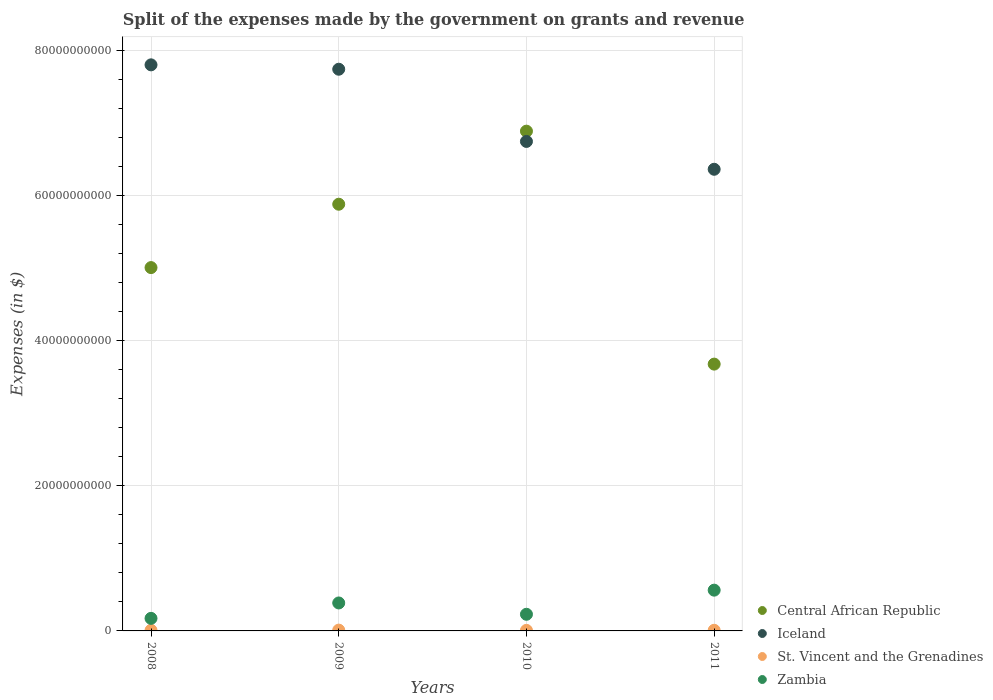How many different coloured dotlines are there?
Make the answer very short. 4. What is the expenses made by the government on grants and revenue in St. Vincent and the Grenadines in 2010?
Offer a terse response. 7.65e+07. Across all years, what is the maximum expenses made by the government on grants and revenue in Iceland?
Make the answer very short. 7.80e+1. Across all years, what is the minimum expenses made by the government on grants and revenue in Iceland?
Your answer should be compact. 6.36e+1. In which year was the expenses made by the government on grants and revenue in St. Vincent and the Grenadines maximum?
Your answer should be compact. 2009. In which year was the expenses made by the government on grants and revenue in Iceland minimum?
Your answer should be very brief. 2011. What is the total expenses made by the government on grants and revenue in Iceland in the graph?
Provide a short and direct response. 2.87e+11. What is the difference between the expenses made by the government on grants and revenue in Central African Republic in 2011 and the expenses made by the government on grants and revenue in Zambia in 2008?
Keep it short and to the point. 3.51e+1. What is the average expenses made by the government on grants and revenue in St. Vincent and the Grenadines per year?
Your answer should be compact. 9.02e+07. In the year 2008, what is the difference between the expenses made by the government on grants and revenue in St. Vincent and the Grenadines and expenses made by the government on grants and revenue in Central African Republic?
Provide a succinct answer. -5.00e+1. In how many years, is the expenses made by the government on grants and revenue in Central African Republic greater than 8000000000 $?
Make the answer very short. 4. What is the ratio of the expenses made by the government on grants and revenue in Iceland in 2008 to that in 2009?
Ensure brevity in your answer.  1.01. Is the expenses made by the government on grants and revenue in Central African Republic in 2008 less than that in 2010?
Offer a terse response. Yes. What is the difference between the highest and the second highest expenses made by the government on grants and revenue in Iceland?
Your response must be concise. 6.04e+08. What is the difference between the highest and the lowest expenses made by the government on grants and revenue in Zambia?
Ensure brevity in your answer.  3.89e+09. In how many years, is the expenses made by the government on grants and revenue in St. Vincent and the Grenadines greater than the average expenses made by the government on grants and revenue in St. Vincent and the Grenadines taken over all years?
Provide a short and direct response. 1. Is the sum of the expenses made by the government on grants and revenue in St. Vincent and the Grenadines in 2008 and 2010 greater than the maximum expenses made by the government on grants and revenue in Zambia across all years?
Your response must be concise. No. Is it the case that in every year, the sum of the expenses made by the government on grants and revenue in Central African Republic and expenses made by the government on grants and revenue in St. Vincent and the Grenadines  is greater than the sum of expenses made by the government on grants and revenue in Zambia and expenses made by the government on grants and revenue in Iceland?
Your answer should be compact. No. Is it the case that in every year, the sum of the expenses made by the government on grants and revenue in Iceland and expenses made by the government on grants and revenue in St. Vincent and the Grenadines  is greater than the expenses made by the government on grants and revenue in Zambia?
Provide a short and direct response. Yes. Does the expenses made by the government on grants and revenue in Zambia monotonically increase over the years?
Make the answer very short. No. Is the expenses made by the government on grants and revenue in Iceland strictly greater than the expenses made by the government on grants and revenue in St. Vincent and the Grenadines over the years?
Offer a very short reply. Yes. Is the expenses made by the government on grants and revenue in St. Vincent and the Grenadines strictly less than the expenses made by the government on grants and revenue in Zambia over the years?
Provide a short and direct response. Yes. How many years are there in the graph?
Your answer should be very brief. 4. What is the difference between two consecutive major ticks on the Y-axis?
Your answer should be compact. 2.00e+1. Are the values on the major ticks of Y-axis written in scientific E-notation?
Offer a very short reply. No. Does the graph contain grids?
Your response must be concise. Yes. Where does the legend appear in the graph?
Ensure brevity in your answer.  Bottom right. How many legend labels are there?
Provide a succinct answer. 4. How are the legend labels stacked?
Offer a terse response. Vertical. What is the title of the graph?
Offer a very short reply. Split of the expenses made by the government on grants and revenue. Does "South Asia" appear as one of the legend labels in the graph?
Keep it short and to the point. No. What is the label or title of the X-axis?
Provide a short and direct response. Years. What is the label or title of the Y-axis?
Your answer should be very brief. Expenses (in $). What is the Expenses (in $) in Central African Republic in 2008?
Offer a terse response. 5.01e+1. What is the Expenses (in $) in Iceland in 2008?
Offer a terse response. 7.80e+1. What is the Expenses (in $) of St. Vincent and the Grenadines in 2008?
Ensure brevity in your answer.  8.68e+07. What is the Expenses (in $) of Zambia in 2008?
Offer a terse response. 1.73e+09. What is the Expenses (in $) of Central African Republic in 2009?
Make the answer very short. 5.88e+1. What is the Expenses (in $) of Iceland in 2009?
Ensure brevity in your answer.  7.74e+1. What is the Expenses (in $) of St. Vincent and the Grenadines in 2009?
Provide a succinct answer. 1.11e+08. What is the Expenses (in $) of Zambia in 2009?
Your answer should be very brief. 3.86e+09. What is the Expenses (in $) of Central African Republic in 2010?
Provide a succinct answer. 6.89e+1. What is the Expenses (in $) of Iceland in 2010?
Your response must be concise. 6.75e+1. What is the Expenses (in $) of St. Vincent and the Grenadines in 2010?
Make the answer very short. 7.65e+07. What is the Expenses (in $) in Zambia in 2010?
Offer a very short reply. 2.29e+09. What is the Expenses (in $) in Central African Republic in 2011?
Your response must be concise. 3.68e+1. What is the Expenses (in $) in Iceland in 2011?
Offer a terse response. 6.36e+1. What is the Expenses (in $) of St. Vincent and the Grenadines in 2011?
Your response must be concise. 8.65e+07. What is the Expenses (in $) of Zambia in 2011?
Provide a short and direct response. 5.62e+09. Across all years, what is the maximum Expenses (in $) of Central African Republic?
Your response must be concise. 6.89e+1. Across all years, what is the maximum Expenses (in $) in Iceland?
Your answer should be very brief. 7.80e+1. Across all years, what is the maximum Expenses (in $) in St. Vincent and the Grenadines?
Provide a succinct answer. 1.11e+08. Across all years, what is the maximum Expenses (in $) in Zambia?
Your answer should be compact. 5.62e+09. Across all years, what is the minimum Expenses (in $) in Central African Republic?
Provide a short and direct response. 3.68e+1. Across all years, what is the minimum Expenses (in $) of Iceland?
Your answer should be compact. 6.36e+1. Across all years, what is the minimum Expenses (in $) of St. Vincent and the Grenadines?
Your response must be concise. 7.65e+07. Across all years, what is the minimum Expenses (in $) of Zambia?
Provide a short and direct response. 1.73e+09. What is the total Expenses (in $) of Central African Republic in the graph?
Your response must be concise. 2.15e+11. What is the total Expenses (in $) in Iceland in the graph?
Offer a terse response. 2.87e+11. What is the total Expenses (in $) in St. Vincent and the Grenadines in the graph?
Provide a short and direct response. 3.61e+08. What is the total Expenses (in $) in Zambia in the graph?
Ensure brevity in your answer.  1.35e+1. What is the difference between the Expenses (in $) in Central African Republic in 2008 and that in 2009?
Keep it short and to the point. -8.74e+09. What is the difference between the Expenses (in $) in Iceland in 2008 and that in 2009?
Provide a succinct answer. 6.04e+08. What is the difference between the Expenses (in $) in St. Vincent and the Grenadines in 2008 and that in 2009?
Your response must be concise. -2.40e+07. What is the difference between the Expenses (in $) in Zambia in 2008 and that in 2009?
Provide a succinct answer. -2.12e+09. What is the difference between the Expenses (in $) in Central African Republic in 2008 and that in 2010?
Make the answer very short. -1.88e+1. What is the difference between the Expenses (in $) in Iceland in 2008 and that in 2010?
Your response must be concise. 1.06e+1. What is the difference between the Expenses (in $) in St. Vincent and the Grenadines in 2008 and that in 2010?
Ensure brevity in your answer.  1.03e+07. What is the difference between the Expenses (in $) in Zambia in 2008 and that in 2010?
Keep it short and to the point. -5.63e+08. What is the difference between the Expenses (in $) of Central African Republic in 2008 and that in 2011?
Keep it short and to the point. 1.33e+1. What is the difference between the Expenses (in $) of Iceland in 2008 and that in 2011?
Keep it short and to the point. 1.44e+1. What is the difference between the Expenses (in $) in Zambia in 2008 and that in 2011?
Ensure brevity in your answer.  -3.89e+09. What is the difference between the Expenses (in $) of Central African Republic in 2009 and that in 2010?
Your answer should be very brief. -1.01e+1. What is the difference between the Expenses (in $) of Iceland in 2009 and that in 2010?
Provide a short and direct response. 9.95e+09. What is the difference between the Expenses (in $) of St. Vincent and the Grenadines in 2009 and that in 2010?
Provide a succinct answer. 3.43e+07. What is the difference between the Expenses (in $) in Zambia in 2009 and that in 2010?
Ensure brevity in your answer.  1.56e+09. What is the difference between the Expenses (in $) in Central African Republic in 2009 and that in 2011?
Make the answer very short. 2.20e+1. What is the difference between the Expenses (in $) in Iceland in 2009 and that in 2011?
Make the answer very short. 1.38e+1. What is the difference between the Expenses (in $) in St. Vincent and the Grenadines in 2009 and that in 2011?
Your answer should be very brief. 2.43e+07. What is the difference between the Expenses (in $) of Zambia in 2009 and that in 2011?
Offer a terse response. -1.76e+09. What is the difference between the Expenses (in $) of Central African Republic in 2010 and that in 2011?
Your response must be concise. 3.21e+1. What is the difference between the Expenses (in $) in Iceland in 2010 and that in 2011?
Your response must be concise. 3.84e+09. What is the difference between the Expenses (in $) in St. Vincent and the Grenadines in 2010 and that in 2011?
Offer a terse response. -1.00e+07. What is the difference between the Expenses (in $) in Zambia in 2010 and that in 2011?
Your response must be concise. -3.33e+09. What is the difference between the Expenses (in $) of Central African Republic in 2008 and the Expenses (in $) of Iceland in 2009?
Your response must be concise. -2.73e+1. What is the difference between the Expenses (in $) of Central African Republic in 2008 and the Expenses (in $) of St. Vincent and the Grenadines in 2009?
Your response must be concise. 5.00e+1. What is the difference between the Expenses (in $) of Central African Republic in 2008 and the Expenses (in $) of Zambia in 2009?
Make the answer very short. 4.62e+1. What is the difference between the Expenses (in $) in Iceland in 2008 and the Expenses (in $) in St. Vincent and the Grenadines in 2009?
Your answer should be very brief. 7.79e+1. What is the difference between the Expenses (in $) of Iceland in 2008 and the Expenses (in $) of Zambia in 2009?
Offer a terse response. 7.42e+1. What is the difference between the Expenses (in $) in St. Vincent and the Grenadines in 2008 and the Expenses (in $) in Zambia in 2009?
Provide a succinct answer. -3.77e+09. What is the difference between the Expenses (in $) of Central African Republic in 2008 and the Expenses (in $) of Iceland in 2010?
Keep it short and to the point. -1.74e+1. What is the difference between the Expenses (in $) in Central African Republic in 2008 and the Expenses (in $) in St. Vincent and the Grenadines in 2010?
Offer a very short reply. 5.00e+1. What is the difference between the Expenses (in $) in Central African Republic in 2008 and the Expenses (in $) in Zambia in 2010?
Make the answer very short. 4.78e+1. What is the difference between the Expenses (in $) of Iceland in 2008 and the Expenses (in $) of St. Vincent and the Grenadines in 2010?
Provide a short and direct response. 7.80e+1. What is the difference between the Expenses (in $) of Iceland in 2008 and the Expenses (in $) of Zambia in 2010?
Your answer should be very brief. 7.57e+1. What is the difference between the Expenses (in $) of St. Vincent and the Grenadines in 2008 and the Expenses (in $) of Zambia in 2010?
Your answer should be very brief. -2.21e+09. What is the difference between the Expenses (in $) of Central African Republic in 2008 and the Expenses (in $) of Iceland in 2011?
Give a very brief answer. -1.36e+1. What is the difference between the Expenses (in $) in Central African Republic in 2008 and the Expenses (in $) in St. Vincent and the Grenadines in 2011?
Offer a very short reply. 5.00e+1. What is the difference between the Expenses (in $) in Central African Republic in 2008 and the Expenses (in $) in Zambia in 2011?
Your answer should be very brief. 4.45e+1. What is the difference between the Expenses (in $) in Iceland in 2008 and the Expenses (in $) in St. Vincent and the Grenadines in 2011?
Ensure brevity in your answer.  7.80e+1. What is the difference between the Expenses (in $) of Iceland in 2008 and the Expenses (in $) of Zambia in 2011?
Ensure brevity in your answer.  7.24e+1. What is the difference between the Expenses (in $) of St. Vincent and the Grenadines in 2008 and the Expenses (in $) of Zambia in 2011?
Provide a short and direct response. -5.53e+09. What is the difference between the Expenses (in $) of Central African Republic in 2009 and the Expenses (in $) of Iceland in 2010?
Make the answer very short. -8.66e+09. What is the difference between the Expenses (in $) in Central African Republic in 2009 and the Expenses (in $) in St. Vincent and the Grenadines in 2010?
Your response must be concise. 5.87e+1. What is the difference between the Expenses (in $) of Central African Republic in 2009 and the Expenses (in $) of Zambia in 2010?
Your response must be concise. 5.65e+1. What is the difference between the Expenses (in $) in Iceland in 2009 and the Expenses (in $) in St. Vincent and the Grenadines in 2010?
Your answer should be compact. 7.74e+1. What is the difference between the Expenses (in $) in Iceland in 2009 and the Expenses (in $) in Zambia in 2010?
Your response must be concise. 7.51e+1. What is the difference between the Expenses (in $) in St. Vincent and the Grenadines in 2009 and the Expenses (in $) in Zambia in 2010?
Your response must be concise. -2.18e+09. What is the difference between the Expenses (in $) in Central African Republic in 2009 and the Expenses (in $) in Iceland in 2011?
Make the answer very short. -4.82e+09. What is the difference between the Expenses (in $) in Central African Republic in 2009 and the Expenses (in $) in St. Vincent and the Grenadines in 2011?
Provide a short and direct response. 5.87e+1. What is the difference between the Expenses (in $) in Central African Republic in 2009 and the Expenses (in $) in Zambia in 2011?
Your response must be concise. 5.32e+1. What is the difference between the Expenses (in $) of Iceland in 2009 and the Expenses (in $) of St. Vincent and the Grenadines in 2011?
Ensure brevity in your answer.  7.73e+1. What is the difference between the Expenses (in $) of Iceland in 2009 and the Expenses (in $) of Zambia in 2011?
Keep it short and to the point. 7.18e+1. What is the difference between the Expenses (in $) in St. Vincent and the Grenadines in 2009 and the Expenses (in $) in Zambia in 2011?
Ensure brevity in your answer.  -5.51e+09. What is the difference between the Expenses (in $) of Central African Republic in 2010 and the Expenses (in $) of Iceland in 2011?
Provide a succinct answer. 5.25e+09. What is the difference between the Expenses (in $) of Central African Republic in 2010 and the Expenses (in $) of St. Vincent and the Grenadines in 2011?
Your response must be concise. 6.88e+1. What is the difference between the Expenses (in $) in Central African Republic in 2010 and the Expenses (in $) in Zambia in 2011?
Provide a succinct answer. 6.33e+1. What is the difference between the Expenses (in $) of Iceland in 2010 and the Expenses (in $) of St. Vincent and the Grenadines in 2011?
Ensure brevity in your answer.  6.74e+1. What is the difference between the Expenses (in $) of Iceland in 2010 and the Expenses (in $) of Zambia in 2011?
Provide a short and direct response. 6.19e+1. What is the difference between the Expenses (in $) of St. Vincent and the Grenadines in 2010 and the Expenses (in $) of Zambia in 2011?
Ensure brevity in your answer.  -5.54e+09. What is the average Expenses (in $) in Central African Republic per year?
Your answer should be very brief. 5.36e+1. What is the average Expenses (in $) of Iceland per year?
Ensure brevity in your answer.  7.16e+1. What is the average Expenses (in $) in St. Vincent and the Grenadines per year?
Offer a terse response. 9.02e+07. What is the average Expenses (in $) of Zambia per year?
Your answer should be compact. 3.38e+09. In the year 2008, what is the difference between the Expenses (in $) of Central African Republic and Expenses (in $) of Iceland?
Make the answer very short. -2.79e+1. In the year 2008, what is the difference between the Expenses (in $) of Central African Republic and Expenses (in $) of St. Vincent and the Grenadines?
Make the answer very short. 5.00e+1. In the year 2008, what is the difference between the Expenses (in $) of Central African Republic and Expenses (in $) of Zambia?
Keep it short and to the point. 4.84e+1. In the year 2008, what is the difference between the Expenses (in $) of Iceland and Expenses (in $) of St. Vincent and the Grenadines?
Your answer should be compact. 7.80e+1. In the year 2008, what is the difference between the Expenses (in $) of Iceland and Expenses (in $) of Zambia?
Your response must be concise. 7.63e+1. In the year 2008, what is the difference between the Expenses (in $) of St. Vincent and the Grenadines and Expenses (in $) of Zambia?
Give a very brief answer. -1.64e+09. In the year 2009, what is the difference between the Expenses (in $) of Central African Republic and Expenses (in $) of Iceland?
Offer a very short reply. -1.86e+1. In the year 2009, what is the difference between the Expenses (in $) in Central African Republic and Expenses (in $) in St. Vincent and the Grenadines?
Your response must be concise. 5.87e+1. In the year 2009, what is the difference between the Expenses (in $) in Central African Republic and Expenses (in $) in Zambia?
Offer a terse response. 5.50e+1. In the year 2009, what is the difference between the Expenses (in $) of Iceland and Expenses (in $) of St. Vincent and the Grenadines?
Give a very brief answer. 7.73e+1. In the year 2009, what is the difference between the Expenses (in $) in Iceland and Expenses (in $) in Zambia?
Your response must be concise. 7.36e+1. In the year 2009, what is the difference between the Expenses (in $) of St. Vincent and the Grenadines and Expenses (in $) of Zambia?
Keep it short and to the point. -3.74e+09. In the year 2010, what is the difference between the Expenses (in $) in Central African Republic and Expenses (in $) in Iceland?
Offer a terse response. 1.42e+09. In the year 2010, what is the difference between the Expenses (in $) in Central African Republic and Expenses (in $) in St. Vincent and the Grenadines?
Your answer should be compact. 6.88e+1. In the year 2010, what is the difference between the Expenses (in $) in Central African Republic and Expenses (in $) in Zambia?
Keep it short and to the point. 6.66e+1. In the year 2010, what is the difference between the Expenses (in $) of Iceland and Expenses (in $) of St. Vincent and the Grenadines?
Your answer should be compact. 6.74e+1. In the year 2010, what is the difference between the Expenses (in $) in Iceland and Expenses (in $) in Zambia?
Ensure brevity in your answer.  6.52e+1. In the year 2010, what is the difference between the Expenses (in $) in St. Vincent and the Grenadines and Expenses (in $) in Zambia?
Your response must be concise. -2.22e+09. In the year 2011, what is the difference between the Expenses (in $) of Central African Republic and Expenses (in $) of Iceland?
Provide a succinct answer. -2.69e+1. In the year 2011, what is the difference between the Expenses (in $) in Central African Republic and Expenses (in $) in St. Vincent and the Grenadines?
Your response must be concise. 3.67e+1. In the year 2011, what is the difference between the Expenses (in $) of Central African Republic and Expenses (in $) of Zambia?
Ensure brevity in your answer.  3.12e+1. In the year 2011, what is the difference between the Expenses (in $) in Iceland and Expenses (in $) in St. Vincent and the Grenadines?
Give a very brief answer. 6.36e+1. In the year 2011, what is the difference between the Expenses (in $) of Iceland and Expenses (in $) of Zambia?
Make the answer very short. 5.80e+1. In the year 2011, what is the difference between the Expenses (in $) of St. Vincent and the Grenadines and Expenses (in $) of Zambia?
Your response must be concise. -5.53e+09. What is the ratio of the Expenses (in $) of Central African Republic in 2008 to that in 2009?
Keep it short and to the point. 0.85. What is the ratio of the Expenses (in $) of Iceland in 2008 to that in 2009?
Give a very brief answer. 1.01. What is the ratio of the Expenses (in $) of St. Vincent and the Grenadines in 2008 to that in 2009?
Ensure brevity in your answer.  0.78. What is the ratio of the Expenses (in $) of Zambia in 2008 to that in 2009?
Provide a succinct answer. 0.45. What is the ratio of the Expenses (in $) of Central African Republic in 2008 to that in 2010?
Your answer should be compact. 0.73. What is the ratio of the Expenses (in $) in Iceland in 2008 to that in 2010?
Ensure brevity in your answer.  1.16. What is the ratio of the Expenses (in $) in St. Vincent and the Grenadines in 2008 to that in 2010?
Your answer should be compact. 1.13. What is the ratio of the Expenses (in $) of Zambia in 2008 to that in 2010?
Give a very brief answer. 0.75. What is the ratio of the Expenses (in $) in Central African Republic in 2008 to that in 2011?
Ensure brevity in your answer.  1.36. What is the ratio of the Expenses (in $) in Iceland in 2008 to that in 2011?
Keep it short and to the point. 1.23. What is the ratio of the Expenses (in $) in Zambia in 2008 to that in 2011?
Your answer should be compact. 0.31. What is the ratio of the Expenses (in $) in Central African Republic in 2009 to that in 2010?
Give a very brief answer. 0.85. What is the ratio of the Expenses (in $) of Iceland in 2009 to that in 2010?
Your answer should be very brief. 1.15. What is the ratio of the Expenses (in $) of St. Vincent and the Grenadines in 2009 to that in 2010?
Keep it short and to the point. 1.45. What is the ratio of the Expenses (in $) of Zambia in 2009 to that in 2010?
Offer a very short reply. 1.68. What is the ratio of the Expenses (in $) in Central African Republic in 2009 to that in 2011?
Your answer should be very brief. 1.6. What is the ratio of the Expenses (in $) of Iceland in 2009 to that in 2011?
Make the answer very short. 1.22. What is the ratio of the Expenses (in $) in St. Vincent and the Grenadines in 2009 to that in 2011?
Provide a succinct answer. 1.28. What is the ratio of the Expenses (in $) of Zambia in 2009 to that in 2011?
Your answer should be very brief. 0.69. What is the ratio of the Expenses (in $) in Central African Republic in 2010 to that in 2011?
Provide a succinct answer. 1.87. What is the ratio of the Expenses (in $) in Iceland in 2010 to that in 2011?
Ensure brevity in your answer.  1.06. What is the ratio of the Expenses (in $) of St. Vincent and the Grenadines in 2010 to that in 2011?
Offer a terse response. 0.88. What is the ratio of the Expenses (in $) of Zambia in 2010 to that in 2011?
Offer a terse response. 0.41. What is the difference between the highest and the second highest Expenses (in $) of Central African Republic?
Your answer should be very brief. 1.01e+1. What is the difference between the highest and the second highest Expenses (in $) of Iceland?
Your answer should be compact. 6.04e+08. What is the difference between the highest and the second highest Expenses (in $) in St. Vincent and the Grenadines?
Provide a short and direct response. 2.40e+07. What is the difference between the highest and the second highest Expenses (in $) in Zambia?
Your answer should be compact. 1.76e+09. What is the difference between the highest and the lowest Expenses (in $) of Central African Republic?
Provide a short and direct response. 3.21e+1. What is the difference between the highest and the lowest Expenses (in $) of Iceland?
Provide a short and direct response. 1.44e+1. What is the difference between the highest and the lowest Expenses (in $) of St. Vincent and the Grenadines?
Keep it short and to the point. 3.43e+07. What is the difference between the highest and the lowest Expenses (in $) of Zambia?
Ensure brevity in your answer.  3.89e+09. 